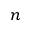<formula> <loc_0><loc_0><loc_500><loc_500>n</formula> 